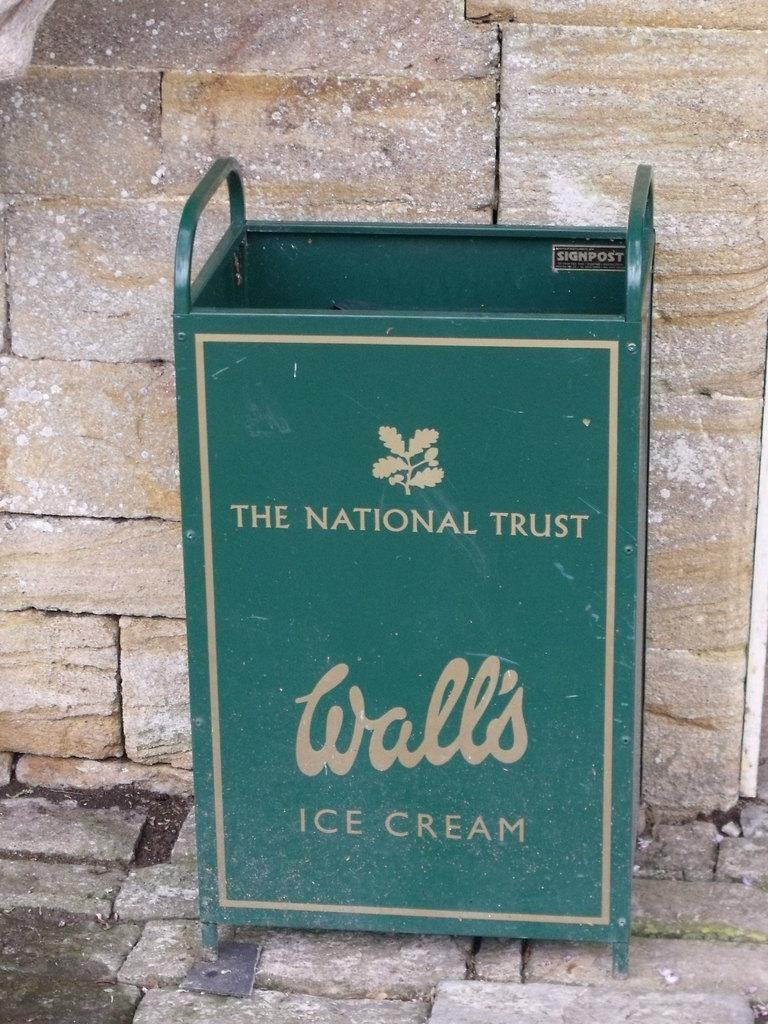<image>
Render a clear and concise summary of the photo. The National Trust is advertised on a green trashcan. 